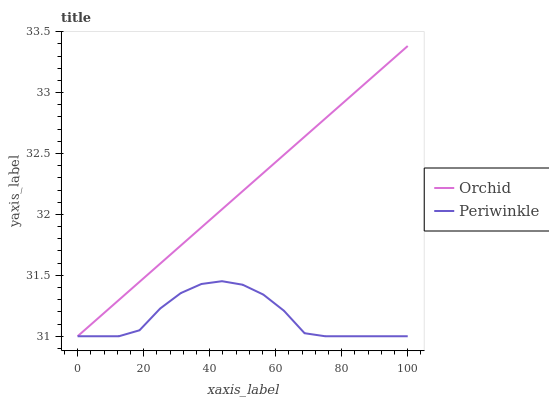Does Periwinkle have the minimum area under the curve?
Answer yes or no. Yes. Does Orchid have the maximum area under the curve?
Answer yes or no. Yes. Does Orchid have the minimum area under the curve?
Answer yes or no. No. Is Orchid the smoothest?
Answer yes or no. Yes. Is Periwinkle the roughest?
Answer yes or no. Yes. Is Orchid the roughest?
Answer yes or no. No. Does Periwinkle have the lowest value?
Answer yes or no. Yes. Does Orchid have the highest value?
Answer yes or no. Yes. Does Periwinkle intersect Orchid?
Answer yes or no. Yes. Is Periwinkle less than Orchid?
Answer yes or no. No. Is Periwinkle greater than Orchid?
Answer yes or no. No. 